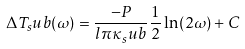Convert formula to latex. <formula><loc_0><loc_0><loc_500><loc_500>\Delta T _ { s } u b ( \omega ) = \frac { - P } { l \pi \kappa _ { s } u b } \frac { 1 } { 2 } \ln ( 2 \omega ) + C</formula> 